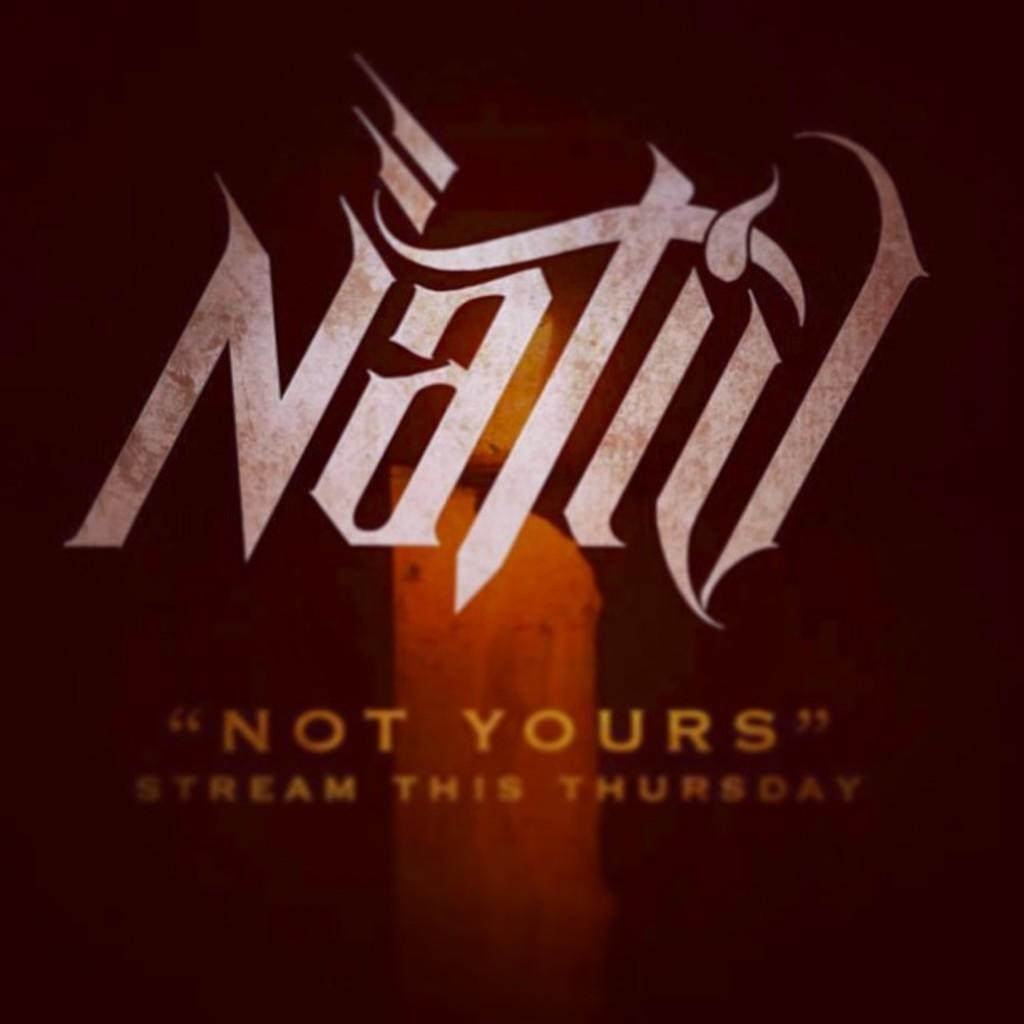<image>
Relay a brief, clear account of the picture shown. An ad for Nativ that says Not Yours  under it . 